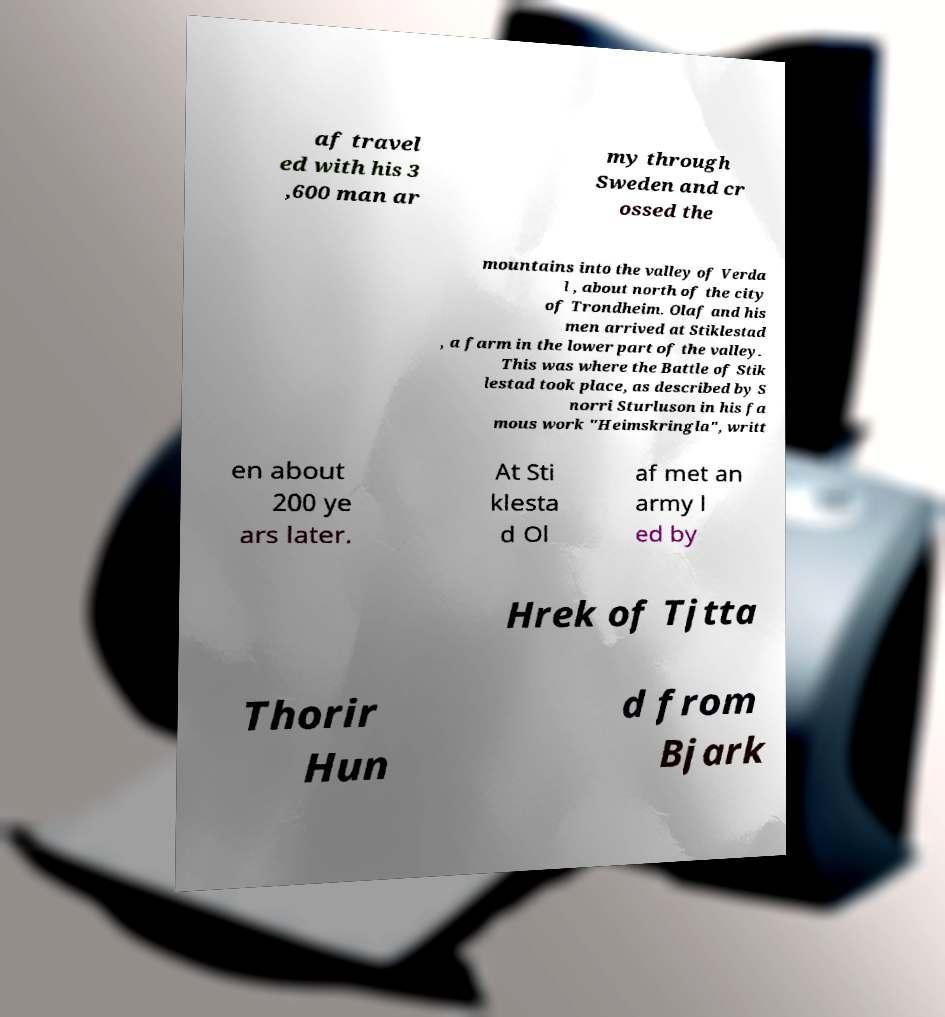What messages or text are displayed in this image? I need them in a readable, typed format. af travel ed with his 3 ,600 man ar my through Sweden and cr ossed the mountains into the valley of Verda l , about north of the city of Trondheim. Olaf and his men arrived at Stiklestad , a farm in the lower part of the valley. This was where the Battle of Stik lestad took place, as described by S norri Sturluson in his fa mous work "Heimskringla", writt en about 200 ye ars later. At Sti klesta d Ol af met an army l ed by Hrek of Tjtta Thorir Hun d from Bjark 